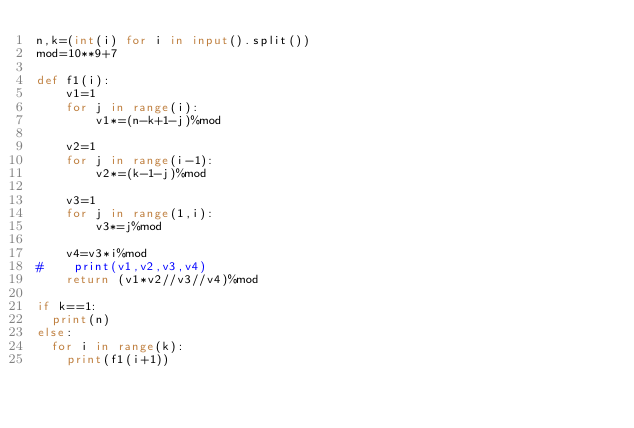Convert code to text. <code><loc_0><loc_0><loc_500><loc_500><_Python_>n,k=(int(i) for i in input().split())
mod=10**9+7

def f1(i):
    v1=1
    for j in range(i):
        v1*=(n-k+1-j)%mod
    
    v2=1
    for j in range(i-1):
        v2*=(k-1-j)%mod
    
    v3=1
    for j in range(1,i):
        v3*=j%mod
    
    v4=v3*i%mod
#    print(v1,v2,v3,v4)
    return (v1*v2//v3//v4)%mod

if k==1:
  print(n)
else:
  for i in range(k):
    print(f1(i+1))

</code> 